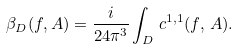<formula> <loc_0><loc_0><loc_500><loc_500>\beta _ { D } ( f , A ) = \frac { i } { 2 4 \pi ^ { 3 } } \int _ { D } \, c ^ { 1 , 1 } ( f , \, A ) .</formula> 